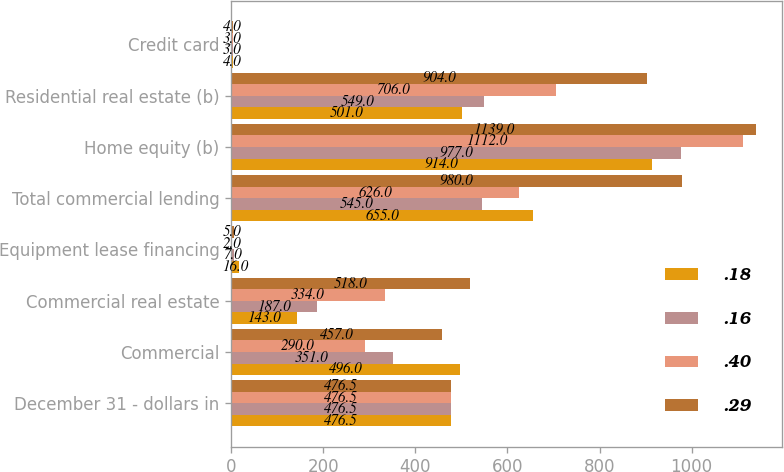<chart> <loc_0><loc_0><loc_500><loc_500><stacked_bar_chart><ecel><fcel>December 31 - dollars in<fcel>Commercial<fcel>Commercial real estate<fcel>Equipment lease financing<fcel>Total commercial lending<fcel>Home equity (b)<fcel>Residential real estate (b)<fcel>Credit card<nl><fcel>0.18<fcel>476.5<fcel>496<fcel>143<fcel>16<fcel>655<fcel>914<fcel>501<fcel>4<nl><fcel>0.16<fcel>476.5<fcel>351<fcel>187<fcel>7<fcel>545<fcel>977<fcel>549<fcel>3<nl><fcel>0.4<fcel>476.5<fcel>290<fcel>334<fcel>2<fcel>626<fcel>1112<fcel>706<fcel>3<nl><fcel>0.29<fcel>476.5<fcel>457<fcel>518<fcel>5<fcel>980<fcel>1139<fcel>904<fcel>4<nl></chart> 